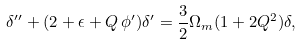<formula> <loc_0><loc_0><loc_500><loc_500>\delta ^ { \prime \prime } + ( 2 + \epsilon + Q \, \phi ^ { \prime } ) \delta ^ { \prime } = \frac { 3 } { 2 } \Omega _ { m } ( 1 + 2 Q ^ { 2 } ) \delta ,</formula> 